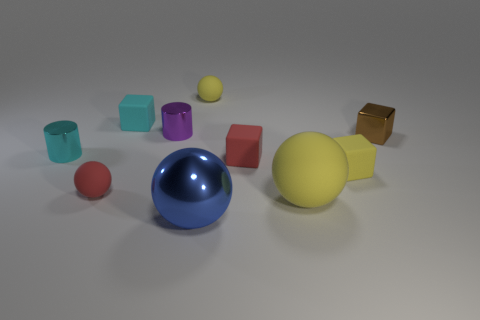There is a small yellow thing right of the yellow object that is left of the red cube; are there any tiny things that are behind it?
Make the answer very short. Yes. How many cylinders are either brown things or large rubber objects?
Keep it short and to the point. 0. What is the material of the large object that is on the left side of the big matte object?
Offer a very short reply. Metal. There is a small ball on the right side of the big shiny object; is its color the same as the large ball that is behind the blue metallic ball?
Keep it short and to the point. Yes. How many things are spheres or big balls?
Ensure brevity in your answer.  4. How many other objects are the same shape as the brown object?
Your answer should be very brief. 3. Is the small yellow cube that is in front of the purple metal thing made of the same material as the cyan object that is in front of the tiny cyan rubber object?
Your answer should be compact. No. The tiny matte object that is both to the left of the red block and on the right side of the large blue object has what shape?
Offer a terse response. Sphere. There is a tiny thing that is behind the brown metallic thing and in front of the cyan block; what material is it made of?
Offer a terse response. Metal. There is a small purple thing that is made of the same material as the blue sphere; what is its shape?
Provide a succinct answer. Cylinder. 